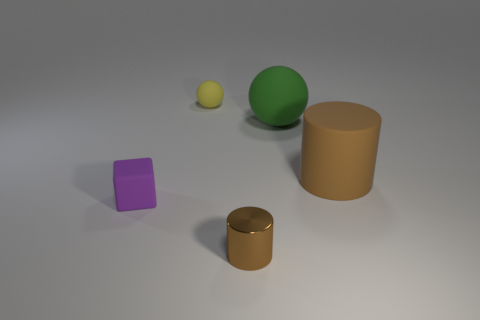There is a green thing; is its size the same as the cylinder that is behind the small purple thing?
Provide a succinct answer. Yes. How many purple things are either small matte blocks or spheres?
Ensure brevity in your answer.  1. What number of cyan shiny cylinders are there?
Offer a very short reply. 0. How big is the brown thing behind the metallic object?
Keep it short and to the point. Large. Does the yellow matte sphere have the same size as the green object?
Your response must be concise. No. What number of things are tiny yellow spheres or things in front of the matte cube?
Offer a terse response. 2. What material is the tiny yellow sphere?
Your response must be concise. Rubber. Is there any other thing of the same color as the small matte block?
Make the answer very short. No. Is the small metallic object the same shape as the big brown matte thing?
Provide a short and direct response. Yes. What is the size of the cylinder that is on the right side of the big object that is left of the brown object that is right of the small brown metallic cylinder?
Provide a short and direct response. Large. 